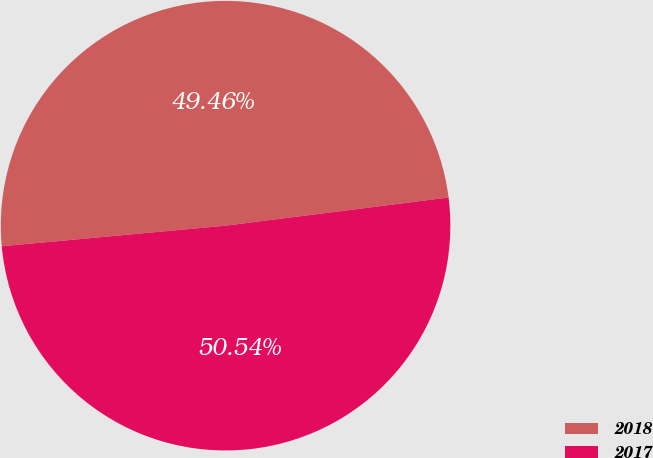Convert chart. <chart><loc_0><loc_0><loc_500><loc_500><pie_chart><fcel>2018<fcel>2017<nl><fcel>49.46%<fcel>50.54%<nl></chart> 